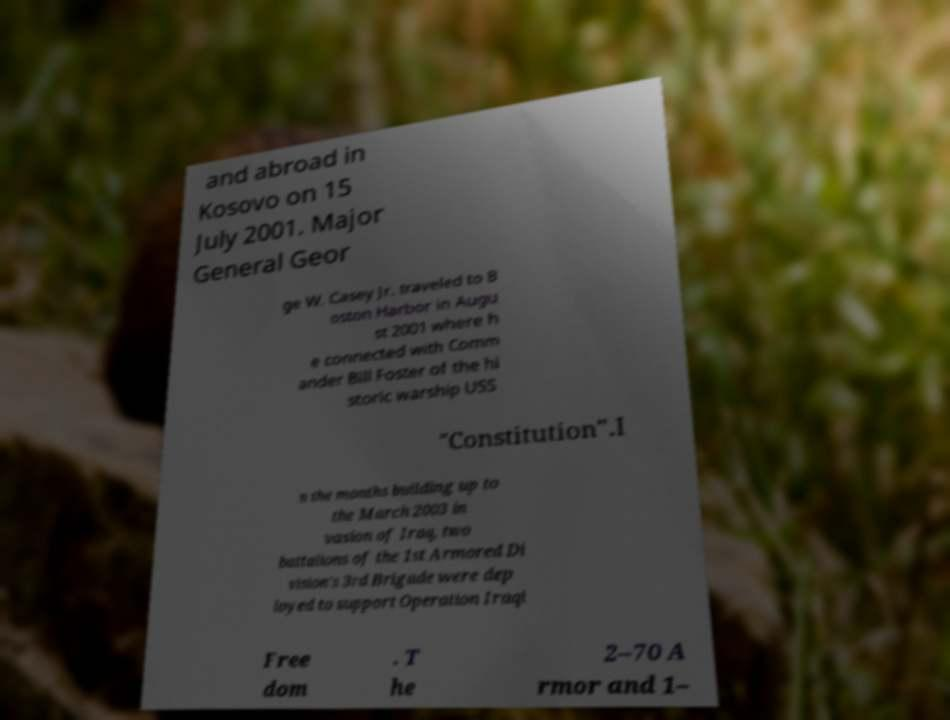There's text embedded in this image that I need extracted. Can you transcribe it verbatim? and abroad in Kosovo on 15 July 2001. Major General Geor ge W. Casey Jr. traveled to B oston Harbor in Augu st 2001 where h e connected with Comm ander Bill Foster of the hi storic warship USS "Constitution".I n the months building up to the March 2003 in vasion of Iraq, two battalions of the 1st Armored Di vision's 3rd Brigade were dep loyed to support Operation Iraqi Free dom . T he 2–70 A rmor and 1– 